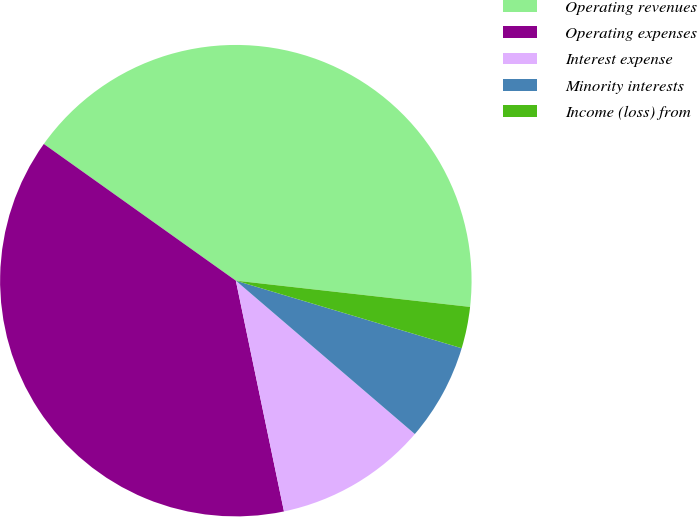<chart> <loc_0><loc_0><loc_500><loc_500><pie_chart><fcel>Operating revenues<fcel>Operating expenses<fcel>Interest expense<fcel>Minority interests<fcel>Income (loss) from<nl><fcel>41.93%<fcel>38.12%<fcel>10.45%<fcel>6.65%<fcel>2.85%<nl></chart> 